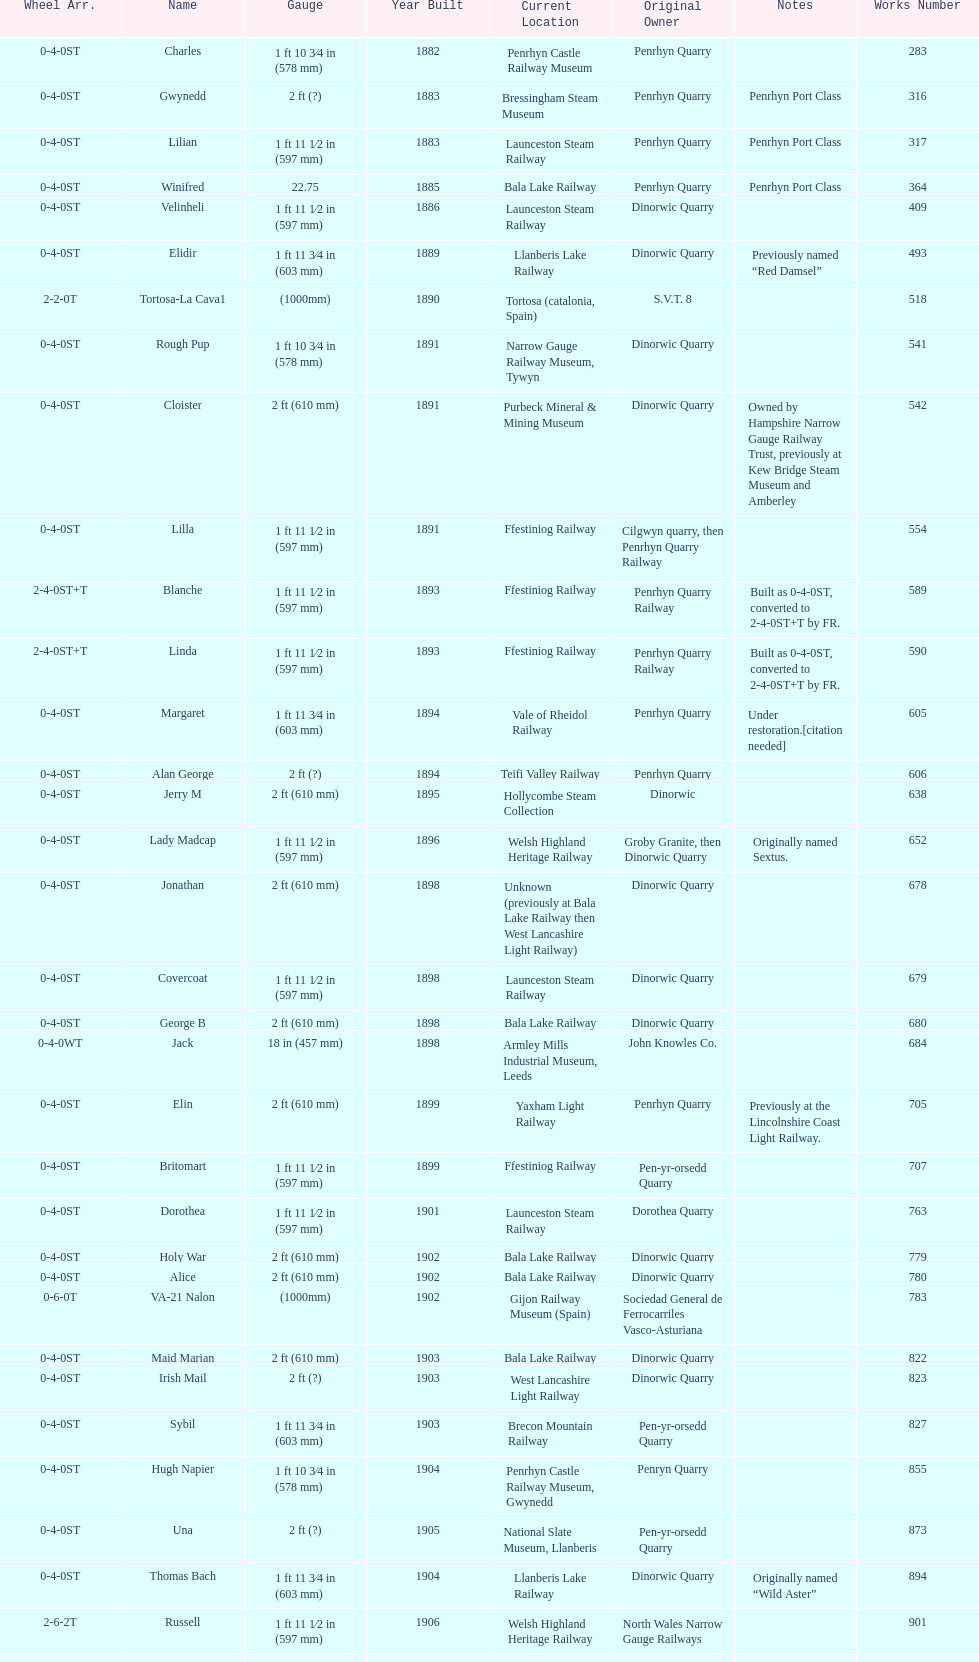What is the total number of preserved hunslet narrow gauge locomotives currently located in ffestiniog railway 554. 